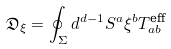<formula> <loc_0><loc_0><loc_500><loc_500>\mathfrak { D } _ { \xi } = \oint _ { \Sigma } d ^ { d - 1 } S ^ { a } \xi ^ { b } T _ { a b } ^ { \text {eff} }</formula> 